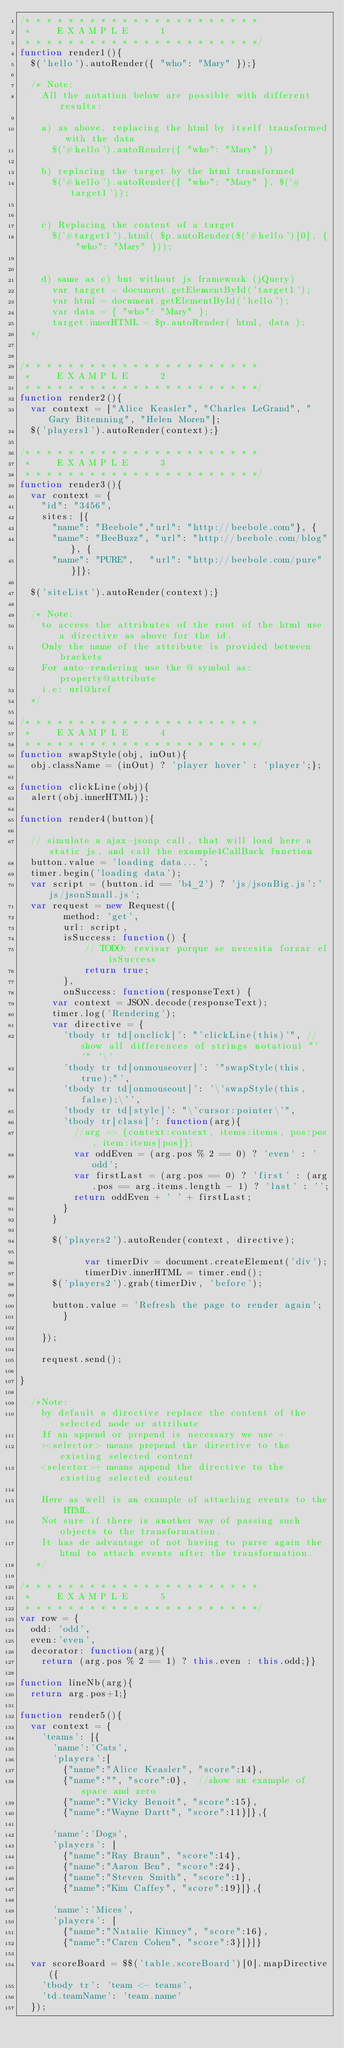Convert code to text. <code><loc_0><loc_0><loc_500><loc_500><_JavaScript_>/* * * * * * * * * * * * * * * * * * * * * *
 *     E X A M P L E      1 
 * * * * * * * * * * * * * * * * * * * * * */			
function render1(){
	$('hello').autoRender({ "who": "Mary" });}

	/* Note: 
	  All the notation below are possible with different results:				

		a) as above. replacing the html by itself transformed with the data
			$('#hello').autoRender({ "who": "Mary" })

		b) replacing the target by the html transformed
			$('#hello').autoRender({ "who": "Mary" }, $('#target1'));
		
		
		c) Replacing the content of a target
			$('#target1').html( $p.autoRender($('#hello')[0], { "who": "Mary" }));


		d) same as c) but without js framework (jQuery)
			var target = document.getElementById('target1'); 
			var html = document.getElementById('hello');
			var data = { "who": "Mary" };
			target.innerHTML = $p.autoRender( html, data );
	*/


/* * * * * * * * * * * * * * * * * * * * * *
 *     E X A M P L E      2 
 * * * * * * * * * * * * * * * * * * * * * */			
function render2(){
	var context = ["Alice Keasler", "Charles LeGrand", "Gary Bitemning", "Helen Moren"];
	$('players1').autoRender(context);}

/* * * * * * * * * * * * * * * * * * * * * *
 *     E X A M P L E      3 
 * * * * * * * * * * * * * * * * * * * * * */			
function render3(){
	var context = {
		"id": "3456",
		sites: [{ 
			"name": "Beebole","url": "http://beebole.com"}, {
			"name": "BeeBuzz", "url": "http://beebole.com/blog"}, {
			"name": "PURE",	  "url": "http://beebole.com/pure"}]};
	
	$('siteList').autoRender(context);}

	/* Note: 
	 	to access the attributes of the root of the html use a directive as above for the id.
		Only the name of the attribute is provided between brackets
		For auto-rendering use the @ symbol as: property@attribute
		i.e: url@href
	*/

/* * * * * * * * * * * * * * * * * * * * * *
 *     E X A M P L E      4 
 * * * * * * * * * * * * * * * * * * * * * */			
function swapStyle(obj, inOut){
	obj.className = (inOut) ? 'player hover' : 'player';};

function clickLine(obj){ 
	alert(obj.innerHTML)};

function render4(button){

	// simulate a ajax-jsonp call, that will load here a static js, and call the example4CallBack function
	button.value = 'loading data...';
	timer.begin('loading data');
	var script = (button.id == 'b4_2') ? 'js/jsonBig.js':'js/jsonSmall.js';
	var request = new Request({
        method: 'get',
        url: script,
        isSuccess: function() {
            // TODO: revisar porque se necesita forzar el isSuccess
            return true;
        },
        onSuccess: function(responseText) { 
			var context = JSON.decode(responseText);
			timer.log('Rendering');
			var directive = {
				'tbody tr td[onclick]': "'clickLine(this)'", //show all differences of strings notationi "' '" '\'
				'tbody tr td[onmouseover]': '"swapStyle(this, true);"',
				'tbody tr td[onmouseout]': '\'swapStyle(this, false);\'',
				'tbody tr td[style]': "\'cursor:pointer\'",
				'tbody tr[class]': function(arg){
					//arg => {context:context, items:items, pos:pos, item:items[pos]};
					var oddEven = (arg.pos % 2 == 0) ? 'even' : 'odd';
					var firstLast = (arg.pos == 0) ? 'first' : (arg.pos == arg.items.length - 1) ? 'last' : '';
					return oddEven + ' ' + firstLast;
				}
			}

			$('players2').autoRender(context, directive);
		
            var timerDiv = document.createElement('div');
            timerDiv.innerHTML = timer.end();
			$('players2').grab(timerDiv, 'before');

			button.value = 'Refresh the page to render again';
        }

    });
    
    request.send();
        
}
	
	/*Note: 
		by default a directive replace the content of the selected node or attribute
		If an append or prepend is necessary we use +
		+<selector> means prepend the directive to the existing selected content
		<selector>+ means append the directive to the existing selected content

		Here as well is an example of attaching events to the HTML.
		Not sure if there is another way of passing such objects to the transformation.
		It has de advantage of not having to parse again the html to attach events after the transformation.
	 */

/* * * * * * * * * * * * * * * * * * * * * *
 *     E X A M P L E      5 
 * * * * * * * * * * * * * * * * * * * * * */			
var row = {
	odd: 'odd',
	even:'even',
	decorator: function(arg){
		return (arg.pos % 2 == 1) ? this.even : this.odd;}}
		
function lineNb(arg){
	return arg.pos+1;}

function render5(){
	var context = {
		'teams': [{
			'name':'Cats',
			'players':[	
				{"name":"Alice Keasler", "score":14}, 
				{"name":"", "score":0},  //show an example of space and zero
				{"name":"Vicky Benoit", "score":15}, 
				{"name":"Wayne Dartt", "score":11}]},{
			
			'name':'Dogs',
			'players': [
				{"name":"Ray Braun", "score":14}, 
				{"name":"Aaron Ben", "score":24}, 
				{"name":"Steven Smith", "score":1}, 
				{"name":"Kim Caffey", "score":19}]},{
			
			'name':'Mices',
			'players': [
				{"name":"Natalie Kinney", "score":16}, 
				{"name":"Caren Cohen", "score":3}]}]}
	
	var scoreBoard = $$('table.scoreBoard')[0].mapDirective({
		'tbody tr': 'team <- teams',
		'td.teamName': 'team.name'
	});

		</code> 